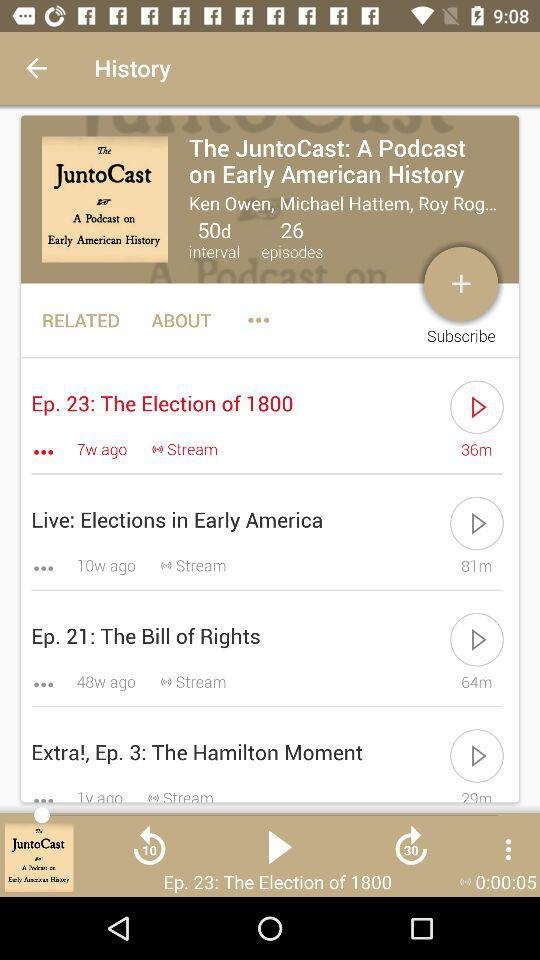What is the interval time of the JuntoCast? The interval time is 50 days. 